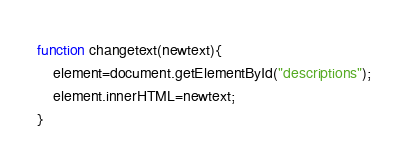Convert code to text. <code><loc_0><loc_0><loc_500><loc_500><_JavaScript_>function changetext(newtext){
    element=document.getElementById("descriptions");
    element.innerHTML=newtext;
}</code> 